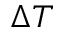Convert formula to latex. <formula><loc_0><loc_0><loc_500><loc_500>\Delta T</formula> 